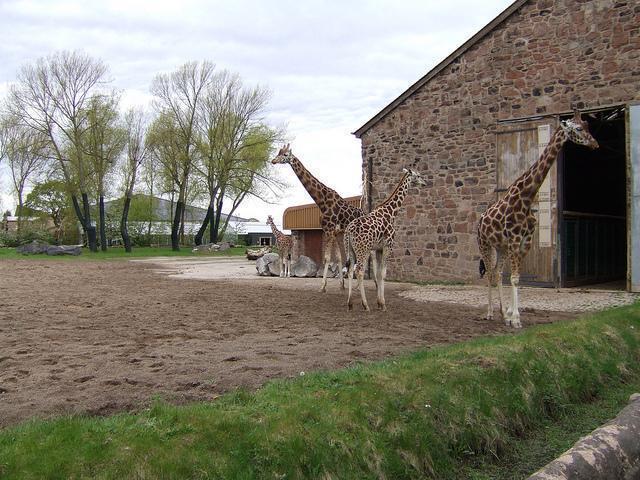What type of animal is shown?
Make your selection and explain in format: 'Answer: answer
Rationale: rationale.'
Options: Domestic, aquatic, nocturnal, wild. Answer: wild.
Rationale: There are several giraffes which are wild animals. 